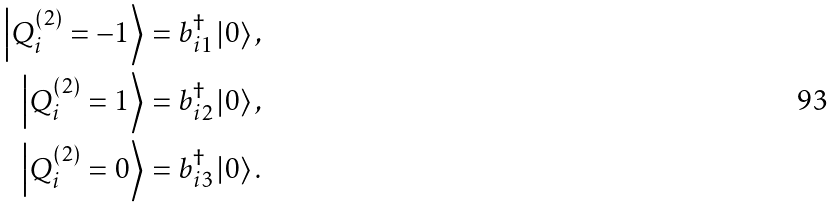Convert formula to latex. <formula><loc_0><loc_0><loc_500><loc_500>\left | Q _ { i } ^ { \left ( 2 \right ) } = - 1 \right \rangle & = b _ { i 1 } ^ { \dag } \left | 0 \right \rangle , \\ \left | Q _ { i } ^ { \left ( 2 \right ) } = 1 \right \rangle & = b _ { i 2 } ^ { \dag } \left | 0 \right \rangle , \\ \left | Q _ { i } ^ { \left ( 2 \right ) } = 0 \right \rangle & = b _ { i 3 } ^ { \dag } \left | 0 \right \rangle .</formula> 